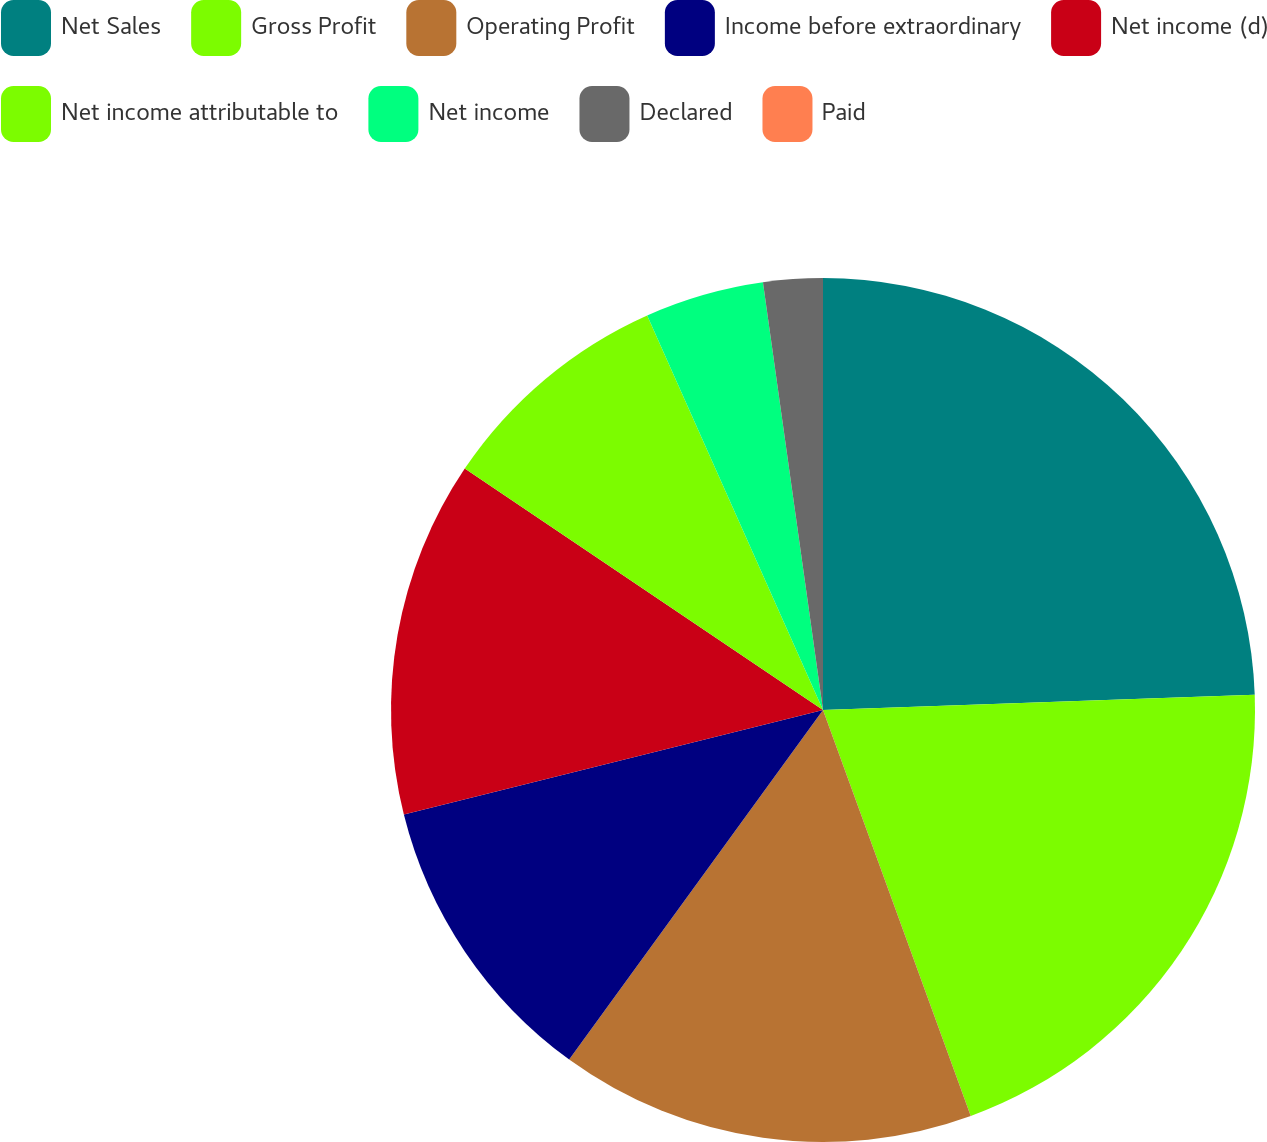Convert chart. <chart><loc_0><loc_0><loc_500><loc_500><pie_chart><fcel>Net Sales<fcel>Gross Profit<fcel>Operating Profit<fcel>Income before extraordinary<fcel>Net income (d)<fcel>Net income attributable to<fcel>Net income<fcel>Declared<fcel>Paid<nl><fcel>24.44%<fcel>20.0%<fcel>15.55%<fcel>11.11%<fcel>13.33%<fcel>8.89%<fcel>4.45%<fcel>2.22%<fcel>0.0%<nl></chart> 